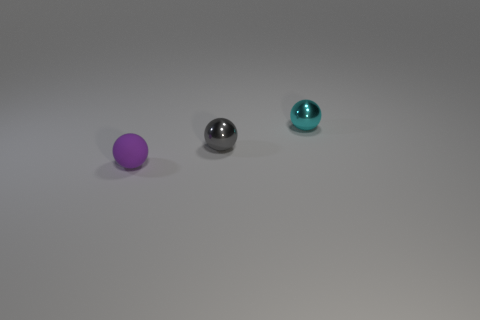There is a tiny gray object that is the same shape as the purple thing; what material is it?
Offer a terse response. Metal. Is there a tiny yellow shiny cylinder?
Keep it short and to the point. No. How big is the ball that is both to the left of the cyan metallic thing and to the right of the tiny purple thing?
Provide a succinct answer. Small. What shape is the small gray object?
Offer a terse response. Sphere. There is a tiny metallic ball that is in front of the small cyan ball; are there any objects behind it?
Provide a short and direct response. Yes. There is a cyan ball that is the same size as the gray ball; what is its material?
Make the answer very short. Metal. Is there a brown metallic ball of the same size as the cyan shiny sphere?
Offer a very short reply. No. What is the object that is on the right side of the tiny gray metallic object made of?
Your answer should be compact. Metal. Is the object that is behind the tiny gray sphere made of the same material as the gray object?
Your response must be concise. Yes. The gray object that is the same size as the purple matte sphere is what shape?
Provide a succinct answer. Sphere. 